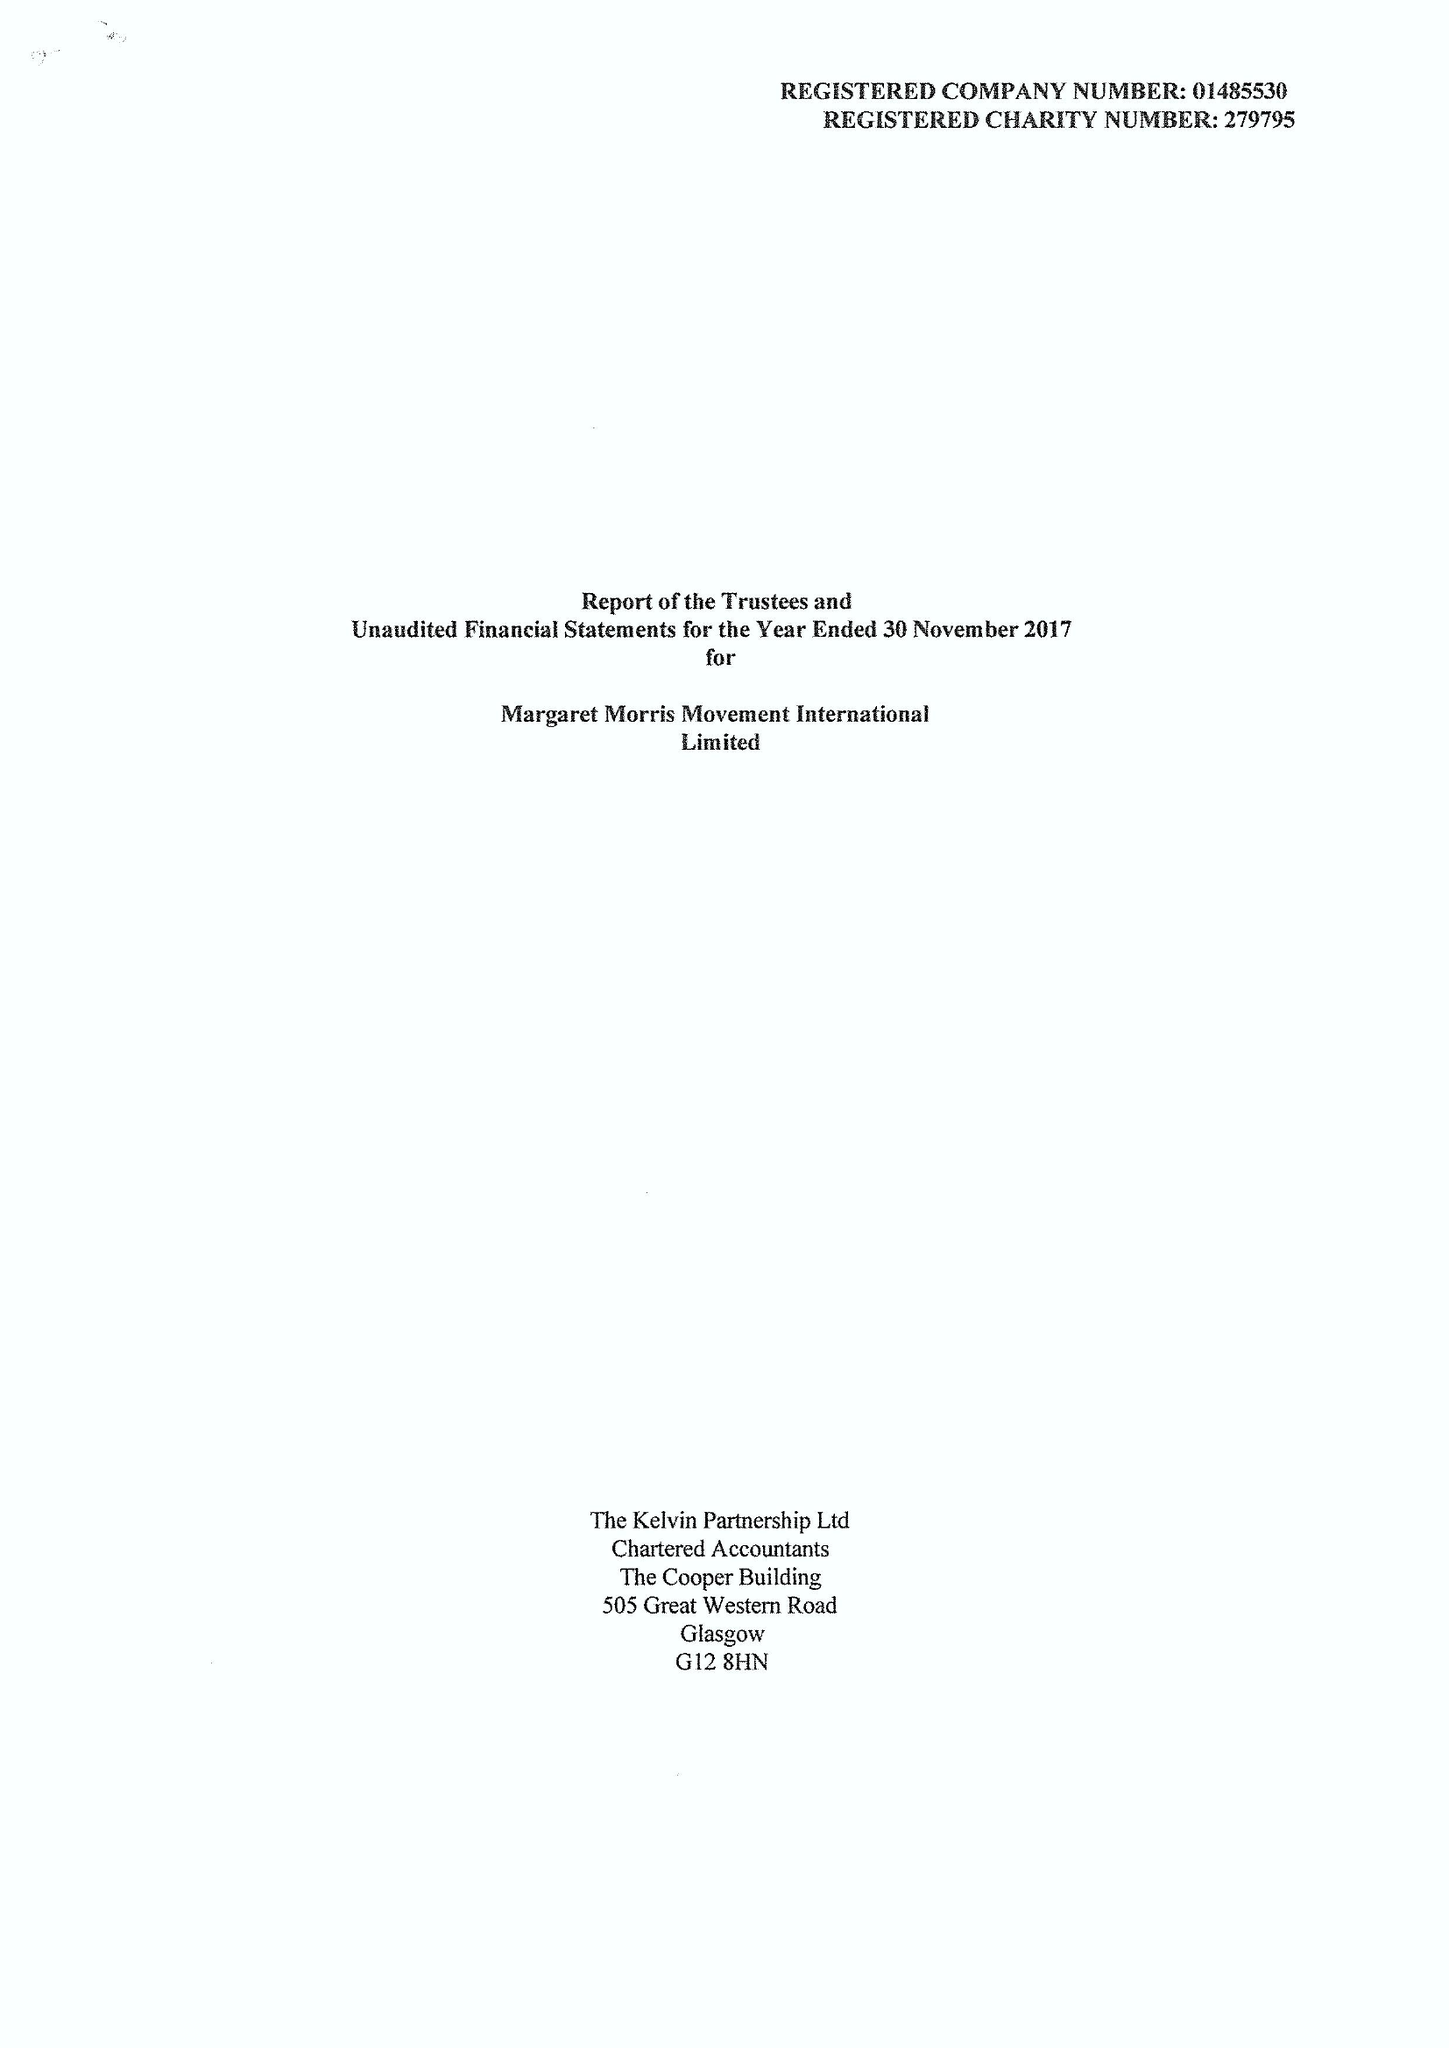What is the value for the address__street_line?
Answer the question using a single word or phrase. None 